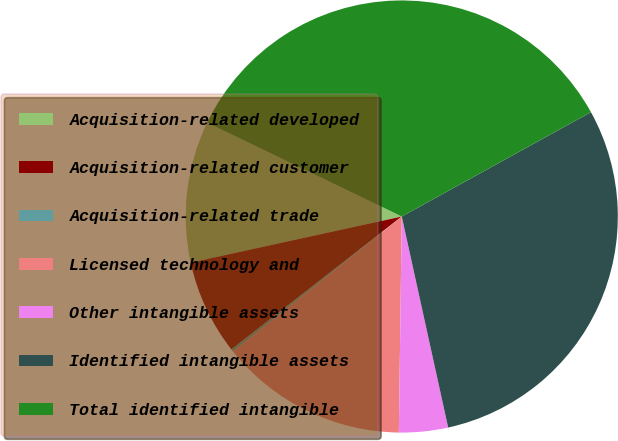Convert chart to OTSL. <chart><loc_0><loc_0><loc_500><loc_500><pie_chart><fcel>Acquisition-related developed<fcel>Acquisition-related customer<fcel>Acquisition-related trade<fcel>Licensed technology and<fcel>Other intangible assets<fcel>Identified intangible assets<fcel>Total identified intangible<nl><fcel>10.58%<fcel>7.12%<fcel>0.2%<fcel>14.04%<fcel>3.66%<fcel>29.58%<fcel>34.82%<nl></chart> 